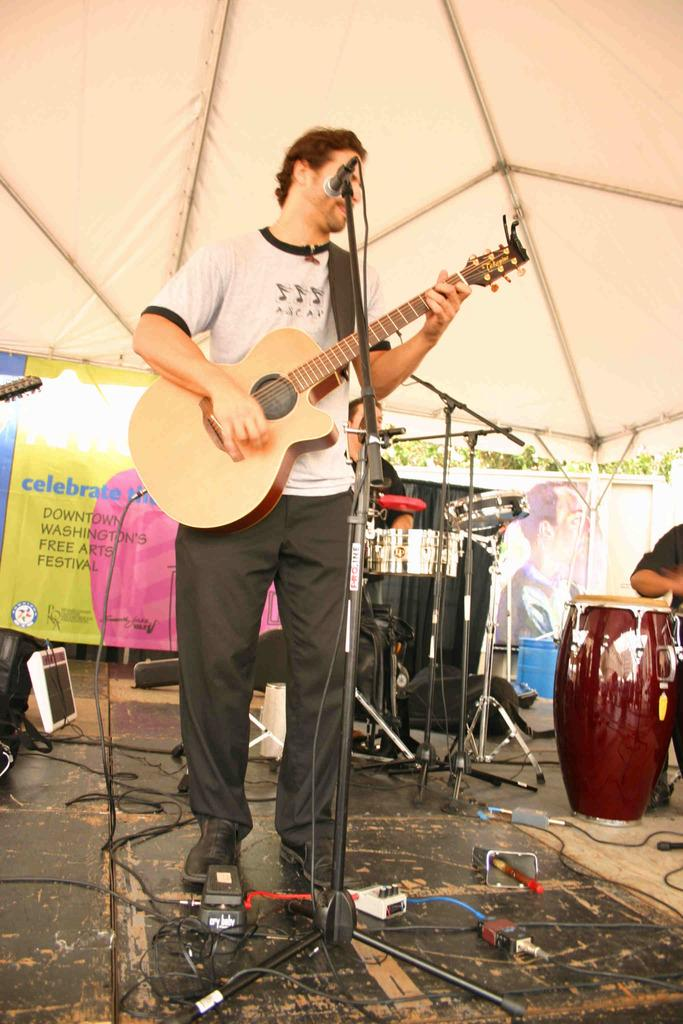What object can be seen in the image that is white in color? There is a white cloth in the image. What is the man in the image doing? The man is standing in the image and holding a guitar. What other musical instrument is present in the image? There are drums in the image. What device is used for amplifying the man's voice in the image? There is a microphone in the image. How many rabbits are hopping around the man in the image? There are no rabbits present in the image. What position is the rat taking in the image? There is no rat present in the image. 